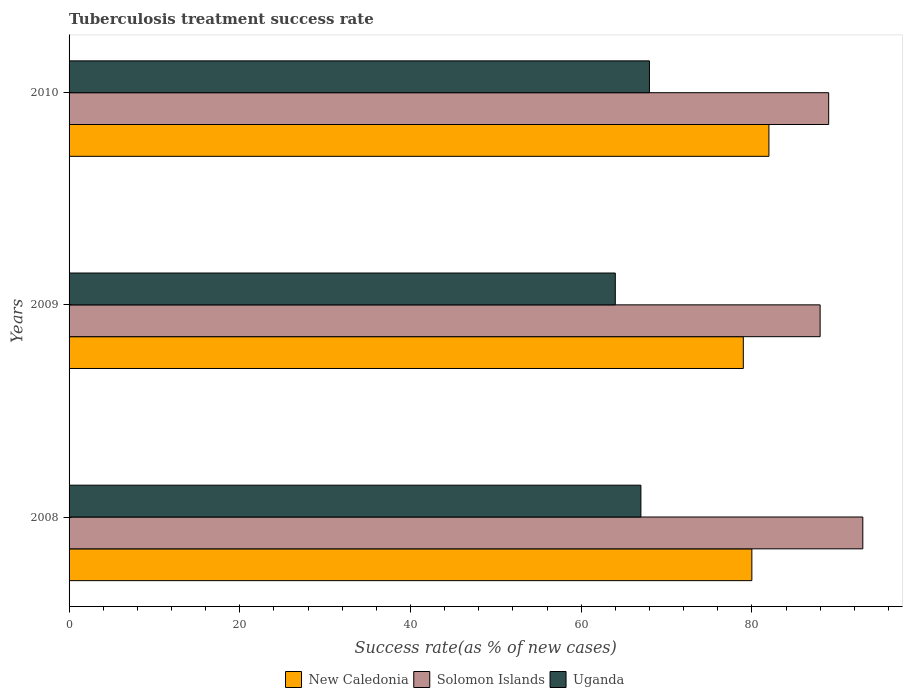How many different coloured bars are there?
Provide a short and direct response. 3. How many groups of bars are there?
Provide a succinct answer. 3. Are the number of bars per tick equal to the number of legend labels?
Provide a succinct answer. Yes. Are the number of bars on each tick of the Y-axis equal?
Provide a short and direct response. Yes. How many bars are there on the 1st tick from the top?
Keep it short and to the point. 3. How many bars are there on the 1st tick from the bottom?
Offer a terse response. 3. What is the label of the 1st group of bars from the top?
Your response must be concise. 2010. What is the tuberculosis treatment success rate in Solomon Islands in 2010?
Your answer should be very brief. 89. Across all years, what is the maximum tuberculosis treatment success rate in New Caledonia?
Keep it short and to the point. 82. Across all years, what is the minimum tuberculosis treatment success rate in Solomon Islands?
Your response must be concise. 88. In which year was the tuberculosis treatment success rate in New Caledonia maximum?
Keep it short and to the point. 2010. What is the total tuberculosis treatment success rate in New Caledonia in the graph?
Offer a terse response. 241. What is the difference between the tuberculosis treatment success rate in Uganda in 2010 and the tuberculosis treatment success rate in Solomon Islands in 2009?
Keep it short and to the point. -20. What is the average tuberculosis treatment success rate in Uganda per year?
Your answer should be very brief. 66.33. What is the ratio of the tuberculosis treatment success rate in Solomon Islands in 2008 to that in 2010?
Your response must be concise. 1.04. Is the difference between the tuberculosis treatment success rate in Solomon Islands in 2008 and 2010 greater than the difference between the tuberculosis treatment success rate in New Caledonia in 2008 and 2010?
Make the answer very short. Yes. What is the difference between the highest and the second highest tuberculosis treatment success rate in New Caledonia?
Keep it short and to the point. 2. What is the difference between the highest and the lowest tuberculosis treatment success rate in Uganda?
Offer a terse response. 4. What does the 3rd bar from the top in 2009 represents?
Keep it short and to the point. New Caledonia. What does the 1st bar from the bottom in 2009 represents?
Provide a succinct answer. New Caledonia. Is it the case that in every year, the sum of the tuberculosis treatment success rate in Solomon Islands and tuberculosis treatment success rate in Uganda is greater than the tuberculosis treatment success rate in New Caledonia?
Your response must be concise. Yes. What is the difference between two consecutive major ticks on the X-axis?
Offer a terse response. 20. Does the graph contain any zero values?
Your answer should be very brief. No. Where does the legend appear in the graph?
Ensure brevity in your answer.  Bottom center. How many legend labels are there?
Your answer should be very brief. 3. How are the legend labels stacked?
Ensure brevity in your answer.  Horizontal. What is the title of the graph?
Provide a succinct answer. Tuberculosis treatment success rate. Does "Other small states" appear as one of the legend labels in the graph?
Provide a succinct answer. No. What is the label or title of the X-axis?
Offer a terse response. Success rate(as % of new cases). What is the Success rate(as % of new cases) in New Caledonia in 2008?
Give a very brief answer. 80. What is the Success rate(as % of new cases) in Solomon Islands in 2008?
Your response must be concise. 93. What is the Success rate(as % of new cases) in New Caledonia in 2009?
Ensure brevity in your answer.  79. What is the Success rate(as % of new cases) in Solomon Islands in 2010?
Give a very brief answer. 89. What is the Success rate(as % of new cases) of Uganda in 2010?
Offer a very short reply. 68. Across all years, what is the maximum Success rate(as % of new cases) of New Caledonia?
Your response must be concise. 82. Across all years, what is the maximum Success rate(as % of new cases) of Solomon Islands?
Offer a very short reply. 93. Across all years, what is the minimum Success rate(as % of new cases) of New Caledonia?
Your response must be concise. 79. Across all years, what is the minimum Success rate(as % of new cases) in Solomon Islands?
Keep it short and to the point. 88. Across all years, what is the minimum Success rate(as % of new cases) of Uganda?
Ensure brevity in your answer.  64. What is the total Success rate(as % of new cases) of New Caledonia in the graph?
Offer a terse response. 241. What is the total Success rate(as % of new cases) in Solomon Islands in the graph?
Offer a very short reply. 270. What is the total Success rate(as % of new cases) of Uganda in the graph?
Offer a terse response. 199. What is the difference between the Success rate(as % of new cases) of Uganda in 2008 and that in 2009?
Your response must be concise. 3. What is the difference between the Success rate(as % of new cases) in Solomon Islands in 2008 and that in 2010?
Give a very brief answer. 4. What is the difference between the Success rate(as % of new cases) in New Caledonia in 2009 and that in 2010?
Your answer should be very brief. -3. What is the difference between the Success rate(as % of new cases) in Solomon Islands in 2009 and that in 2010?
Your answer should be compact. -1. What is the difference between the Success rate(as % of new cases) in Uganda in 2009 and that in 2010?
Give a very brief answer. -4. What is the difference between the Success rate(as % of new cases) in New Caledonia in 2008 and the Success rate(as % of new cases) in Solomon Islands in 2009?
Provide a succinct answer. -8. What is the difference between the Success rate(as % of new cases) of New Caledonia in 2008 and the Success rate(as % of new cases) of Uganda in 2009?
Make the answer very short. 16. What is the difference between the Success rate(as % of new cases) in Solomon Islands in 2008 and the Success rate(as % of new cases) in Uganda in 2009?
Ensure brevity in your answer.  29. What is the difference between the Success rate(as % of new cases) of New Caledonia in 2009 and the Success rate(as % of new cases) of Solomon Islands in 2010?
Offer a very short reply. -10. What is the difference between the Success rate(as % of new cases) in New Caledonia in 2009 and the Success rate(as % of new cases) in Uganda in 2010?
Your answer should be compact. 11. What is the difference between the Success rate(as % of new cases) in Solomon Islands in 2009 and the Success rate(as % of new cases) in Uganda in 2010?
Provide a succinct answer. 20. What is the average Success rate(as % of new cases) in New Caledonia per year?
Make the answer very short. 80.33. What is the average Success rate(as % of new cases) of Uganda per year?
Provide a succinct answer. 66.33. In the year 2008, what is the difference between the Success rate(as % of new cases) of New Caledonia and Success rate(as % of new cases) of Uganda?
Provide a succinct answer. 13. In the year 2009, what is the difference between the Success rate(as % of new cases) of New Caledonia and Success rate(as % of new cases) of Solomon Islands?
Ensure brevity in your answer.  -9. In the year 2009, what is the difference between the Success rate(as % of new cases) in New Caledonia and Success rate(as % of new cases) in Uganda?
Offer a very short reply. 15. In the year 2010, what is the difference between the Success rate(as % of new cases) in Solomon Islands and Success rate(as % of new cases) in Uganda?
Offer a very short reply. 21. What is the ratio of the Success rate(as % of new cases) in New Caledonia in 2008 to that in 2009?
Offer a very short reply. 1.01. What is the ratio of the Success rate(as % of new cases) in Solomon Islands in 2008 to that in 2009?
Keep it short and to the point. 1.06. What is the ratio of the Success rate(as % of new cases) in Uganda in 2008 to that in 2009?
Your answer should be compact. 1.05. What is the ratio of the Success rate(as % of new cases) of New Caledonia in 2008 to that in 2010?
Offer a terse response. 0.98. What is the ratio of the Success rate(as % of new cases) of Solomon Islands in 2008 to that in 2010?
Give a very brief answer. 1.04. What is the ratio of the Success rate(as % of new cases) in New Caledonia in 2009 to that in 2010?
Make the answer very short. 0.96. What is the ratio of the Success rate(as % of new cases) in Solomon Islands in 2009 to that in 2010?
Your response must be concise. 0.99. What is the ratio of the Success rate(as % of new cases) of Uganda in 2009 to that in 2010?
Ensure brevity in your answer.  0.94. What is the difference between the highest and the second highest Success rate(as % of new cases) in New Caledonia?
Provide a succinct answer. 2. What is the difference between the highest and the second highest Success rate(as % of new cases) of Uganda?
Provide a succinct answer. 1. What is the difference between the highest and the lowest Success rate(as % of new cases) of New Caledonia?
Give a very brief answer. 3. What is the difference between the highest and the lowest Success rate(as % of new cases) in Solomon Islands?
Offer a terse response. 5. What is the difference between the highest and the lowest Success rate(as % of new cases) of Uganda?
Ensure brevity in your answer.  4. 